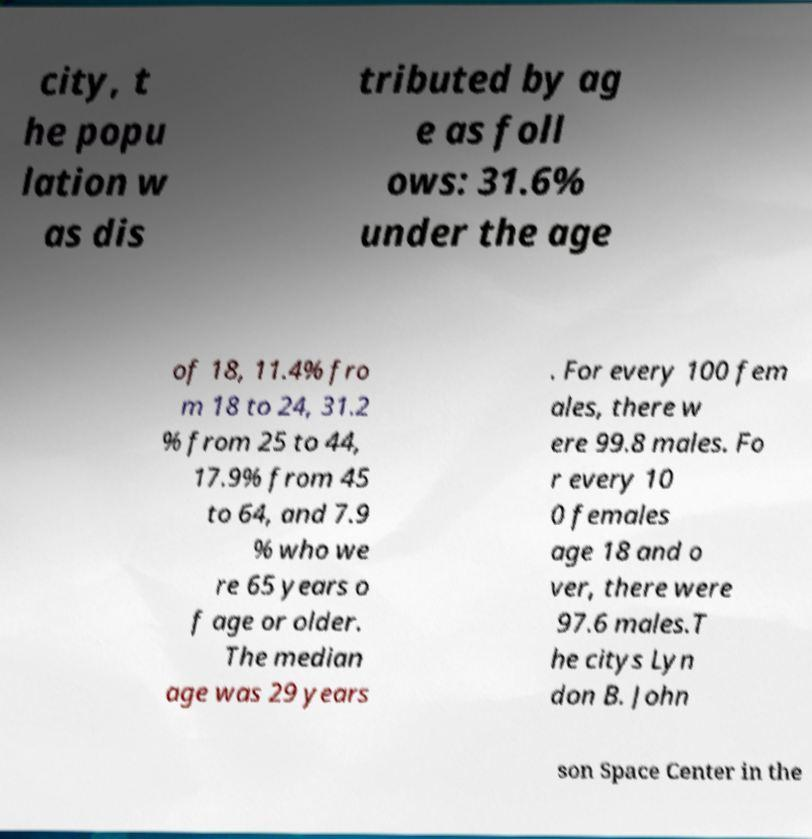There's text embedded in this image that I need extracted. Can you transcribe it verbatim? city, t he popu lation w as dis tributed by ag e as foll ows: 31.6% under the age of 18, 11.4% fro m 18 to 24, 31.2 % from 25 to 44, 17.9% from 45 to 64, and 7.9 % who we re 65 years o f age or older. The median age was 29 years . For every 100 fem ales, there w ere 99.8 males. Fo r every 10 0 females age 18 and o ver, there were 97.6 males.T he citys Lyn don B. John son Space Center in the 